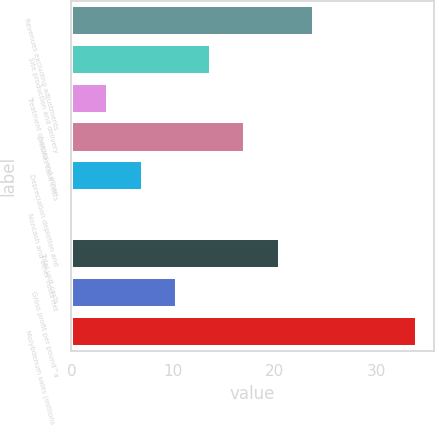Convert chart to OTSL. <chart><loc_0><loc_0><loc_500><loc_500><bar_chart><fcel>Revenues excluding adjustments<fcel>Site production and delivery<fcel>Treatment charges and other<fcel>Unit net cash costs<fcel>Depreciation depletion and<fcel>Noncash and other costs net<fcel>Total unit costs<fcel>Gross profit per pound^a<fcel>Molybdenum sales (millions of<nl><fcel>23.9<fcel>13.76<fcel>3.62<fcel>17.14<fcel>7<fcel>0.24<fcel>20.52<fcel>10.38<fcel>34<nl></chart> 